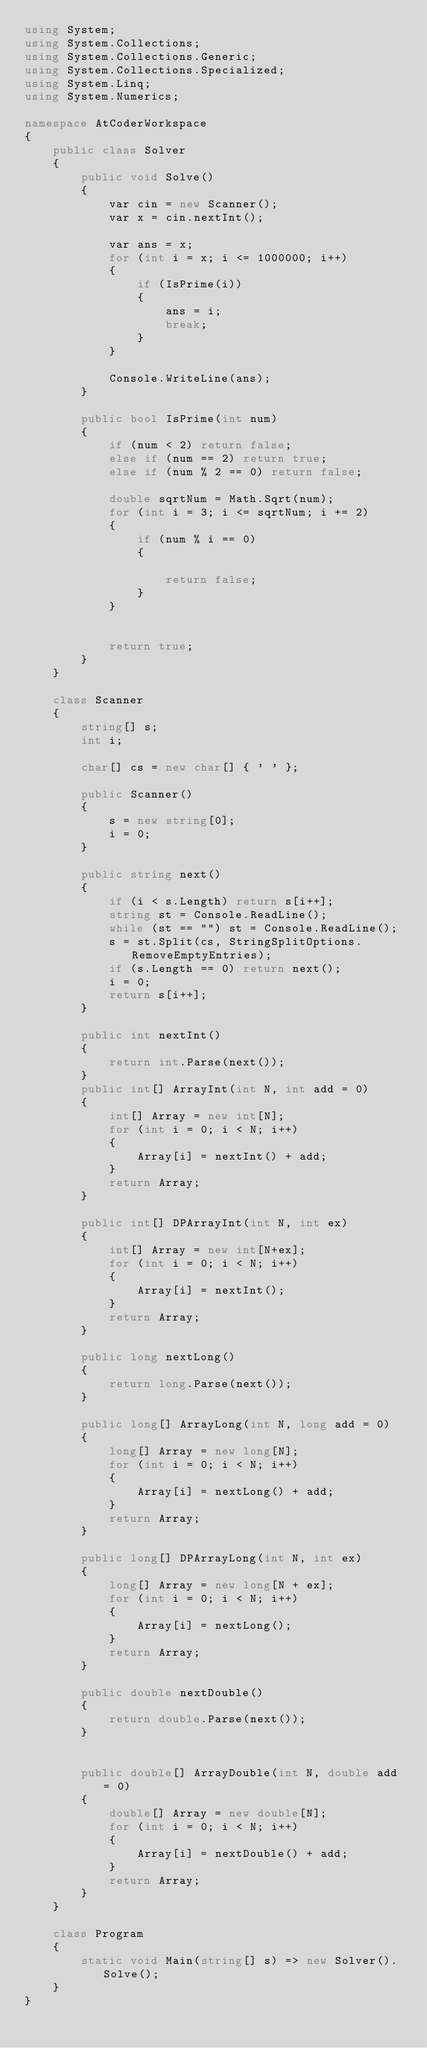<code> <loc_0><loc_0><loc_500><loc_500><_C#_>using System;
using System.Collections;
using System.Collections.Generic;
using System.Collections.Specialized;
using System.Linq;
using System.Numerics;

namespace AtCoderWorkspace
{
    public class Solver
    {
        public void Solve()
        {
            var cin = new Scanner();
            var x = cin.nextInt();

            var ans = x;
            for (int i = x; i <= 1000000; i++)
            {
                if (IsPrime(i))
                {
                    ans = i;
                    break;
                }                
            }

            Console.WriteLine(ans);
        }

        public bool IsPrime(int num)
        {
            if (num < 2) return false;
            else if (num == 2) return true;
            else if (num % 2 == 0) return false;

            double sqrtNum = Math.Sqrt(num);
            for (int i = 3; i <= sqrtNum; i += 2)
            {
                if (num % i == 0)
                {
                    
                    return false;
                }
            }

           
            return true;
        }
    }

    class Scanner
    {
        string[] s;
        int i;

        char[] cs = new char[] { ' ' };

        public Scanner()
        {
            s = new string[0];
            i = 0;
        }

        public string next()
        {
            if (i < s.Length) return s[i++];
            string st = Console.ReadLine();
            while (st == "") st = Console.ReadLine();
            s = st.Split(cs, StringSplitOptions.RemoveEmptyEntries);
            if (s.Length == 0) return next();
            i = 0;
            return s[i++];
        }

        public int nextInt()
        {
            return int.Parse(next());
        }
        public int[] ArrayInt(int N, int add = 0)
        {
            int[] Array = new int[N];
            for (int i = 0; i < N; i++)
            {
                Array[i] = nextInt() + add;
            }
            return Array;
        }

        public int[] DPArrayInt(int N, int ex)
        {
            int[] Array = new int[N+ex];
            for (int i = 0; i < N; i++)
            {
                Array[i] = nextInt();
            }
            return Array;
        }

        public long nextLong()
        {
            return long.Parse(next());
        }

        public long[] ArrayLong(int N, long add = 0)
        {
            long[] Array = new long[N];
            for (int i = 0; i < N; i++)
            {
                Array[i] = nextLong() + add;
            }
            return Array;
        }

        public long[] DPArrayLong(int N, int ex)
        {
            long[] Array = new long[N + ex];
            for (int i = 0; i < N; i++)
            {
                Array[i] = nextLong();
            }
            return Array;
        }

        public double nextDouble()
        {
            return double.Parse(next());
        }


        public double[] ArrayDouble(int N, double add = 0)
        {
            double[] Array = new double[N];
            for (int i = 0; i < N; i++)
            {
                Array[i] = nextDouble() + add;
            }
            return Array;
        }
    }   

    class Program
    {
        static void Main(string[] s) => new Solver().Solve();
    }
}
</code> 